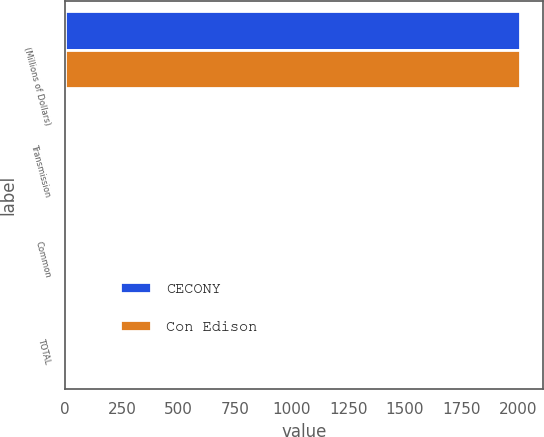Convert chart. <chart><loc_0><loc_0><loc_500><loc_500><stacked_bar_chart><ecel><fcel>(Millions of Dollars)<fcel>Transmission<fcel>Common<fcel>TOTAL<nl><fcel>CECONY<fcel>2011<fcel>1<fcel>8<fcel>9<nl><fcel>Con Edison<fcel>2011<fcel>1<fcel>6<fcel>7<nl></chart> 